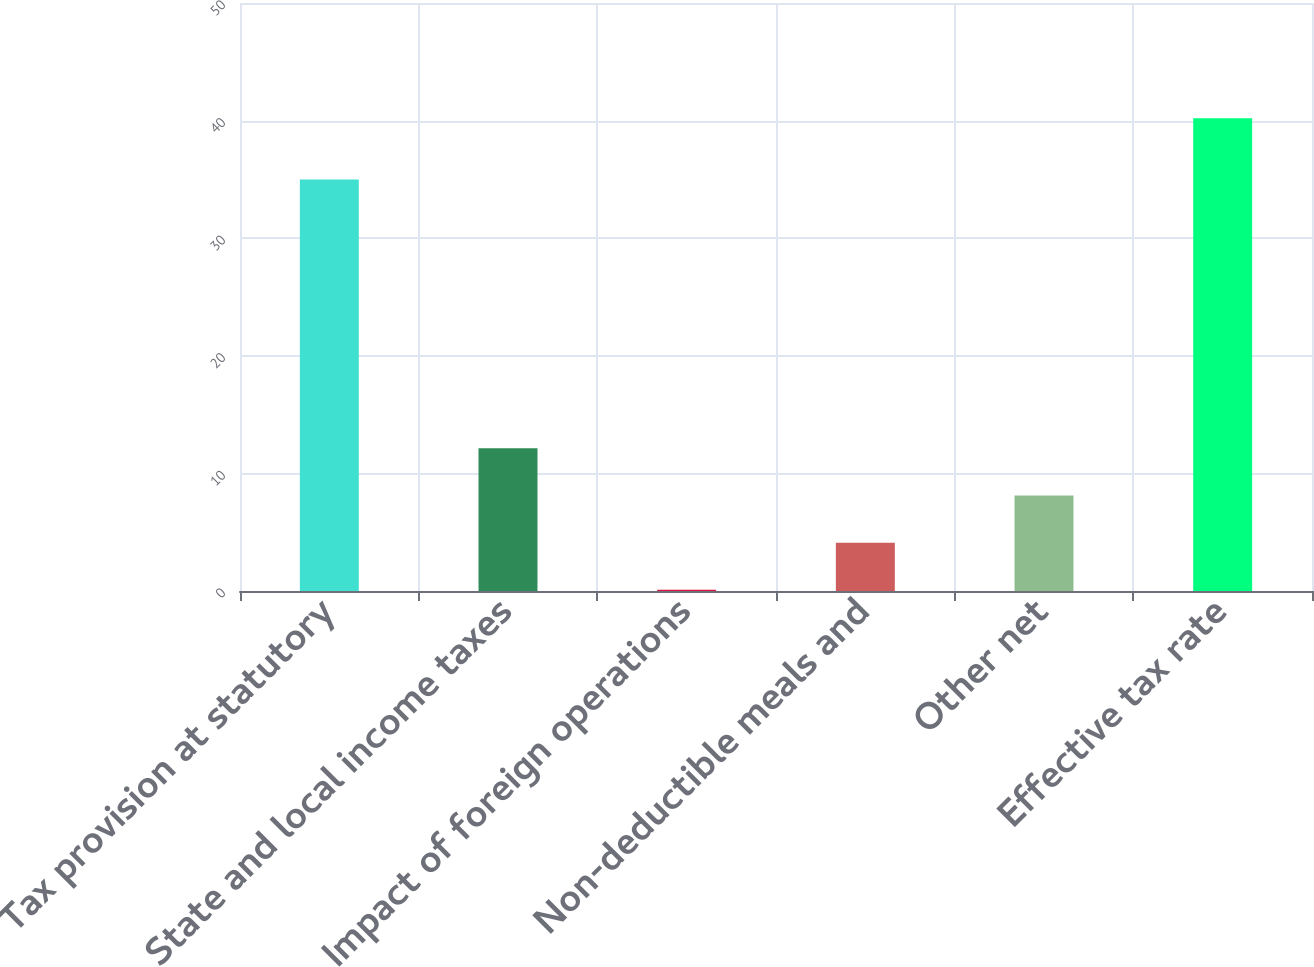Convert chart to OTSL. <chart><loc_0><loc_0><loc_500><loc_500><bar_chart><fcel>Tax provision at statutory<fcel>State and local income taxes<fcel>Impact of foreign operations<fcel>Non-deductible meals and<fcel>Other net<fcel>Effective tax rate<nl><fcel>35<fcel>12.13<fcel>0.1<fcel>4.11<fcel>8.12<fcel>40.2<nl></chart> 